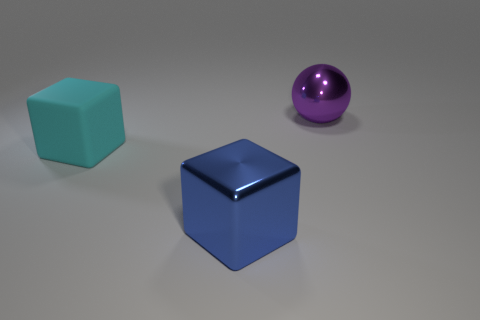Is the shape of the big thing that is on the left side of the large blue shiny object the same as  the big blue shiny thing?
Give a very brief answer. Yes. Are there fewer large balls that are behind the big purple metal ball than cyan matte blocks left of the metallic block?
Provide a short and direct response. Yes. How many other things are the same shape as the big cyan rubber object?
Your answer should be compact. 1. How many green objects are either blocks or big rubber blocks?
Offer a terse response. 0. There is a thing on the right side of the big shiny thing that is to the left of the large purple metallic sphere; what shape is it?
Keep it short and to the point. Sphere. Does the object behind the cyan block have the same size as the cube behind the blue metallic block?
Ensure brevity in your answer.  Yes. Are there any large blocks made of the same material as the purple object?
Provide a short and direct response. Yes. Are there any big metal spheres behind the metal thing that is behind the shiny thing left of the purple shiny thing?
Give a very brief answer. No. Are there any things in front of the cyan thing?
Your answer should be very brief. Yes. How many large blue cubes are behind the big metal thing behind the large matte object?
Provide a short and direct response. 0. 